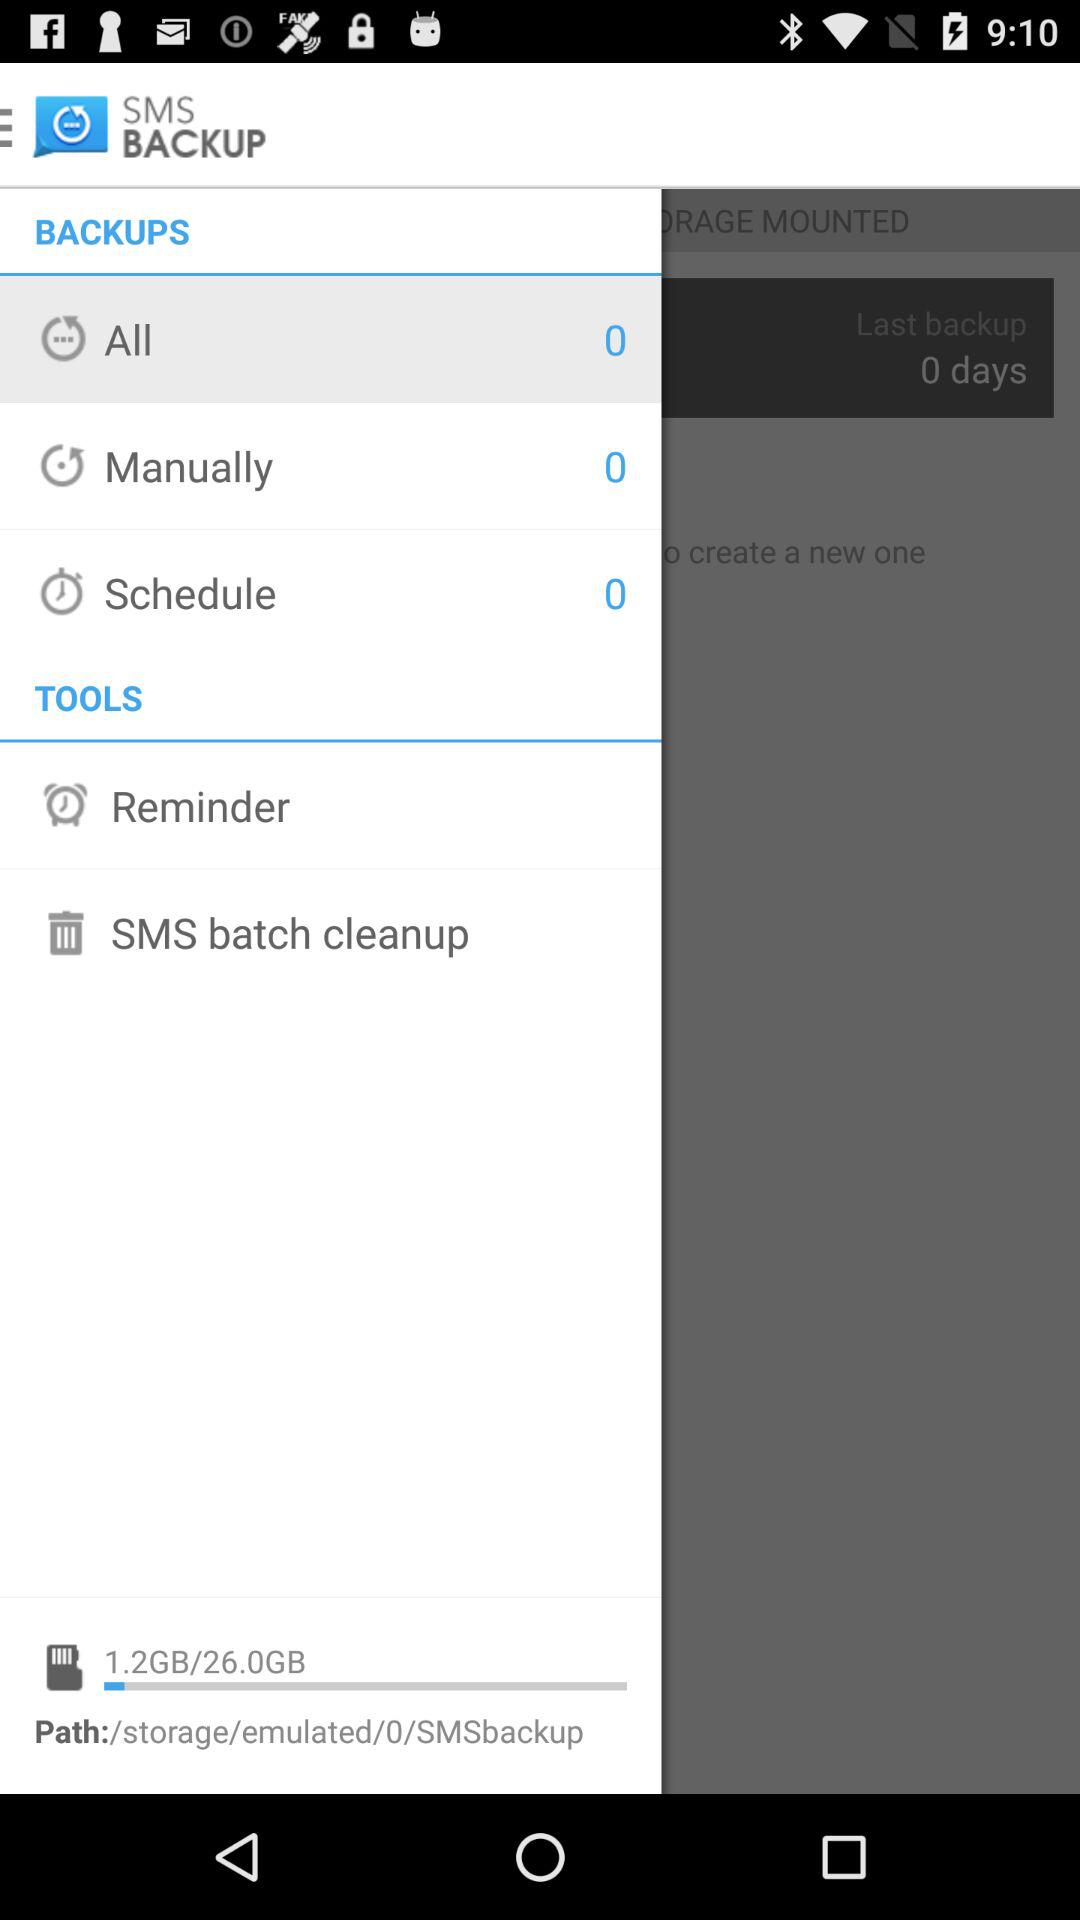What amount of storage is used? The used storage amount is 1.2 GB. 